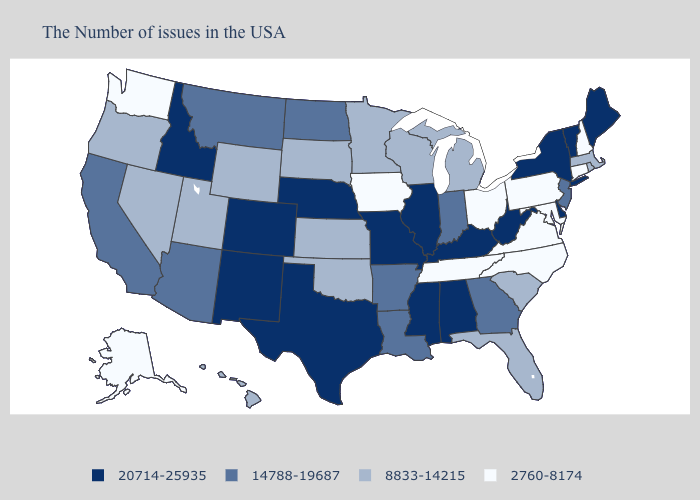What is the value of Colorado?
Keep it brief. 20714-25935. What is the lowest value in states that border Alabama?
Write a very short answer. 2760-8174. Which states have the highest value in the USA?
Be succinct. Maine, Vermont, New York, Delaware, West Virginia, Kentucky, Alabama, Illinois, Mississippi, Missouri, Nebraska, Texas, Colorado, New Mexico, Idaho. Does Indiana have the lowest value in the MidWest?
Short answer required. No. What is the value of North Carolina?
Give a very brief answer. 2760-8174. Name the states that have a value in the range 8833-14215?
Concise answer only. Massachusetts, Rhode Island, South Carolina, Florida, Michigan, Wisconsin, Minnesota, Kansas, Oklahoma, South Dakota, Wyoming, Utah, Nevada, Oregon, Hawaii. Name the states that have a value in the range 14788-19687?
Quick response, please. New Jersey, Georgia, Indiana, Louisiana, Arkansas, North Dakota, Montana, Arizona, California. What is the value of Delaware?
Concise answer only. 20714-25935. Among the states that border Colorado , which have the highest value?
Write a very short answer. Nebraska, New Mexico. Is the legend a continuous bar?
Keep it brief. No. What is the value of Alabama?
Keep it brief. 20714-25935. Does the map have missing data?
Keep it brief. No. What is the value of New Jersey?
Concise answer only. 14788-19687. Name the states that have a value in the range 20714-25935?
Be succinct. Maine, Vermont, New York, Delaware, West Virginia, Kentucky, Alabama, Illinois, Mississippi, Missouri, Nebraska, Texas, Colorado, New Mexico, Idaho. 